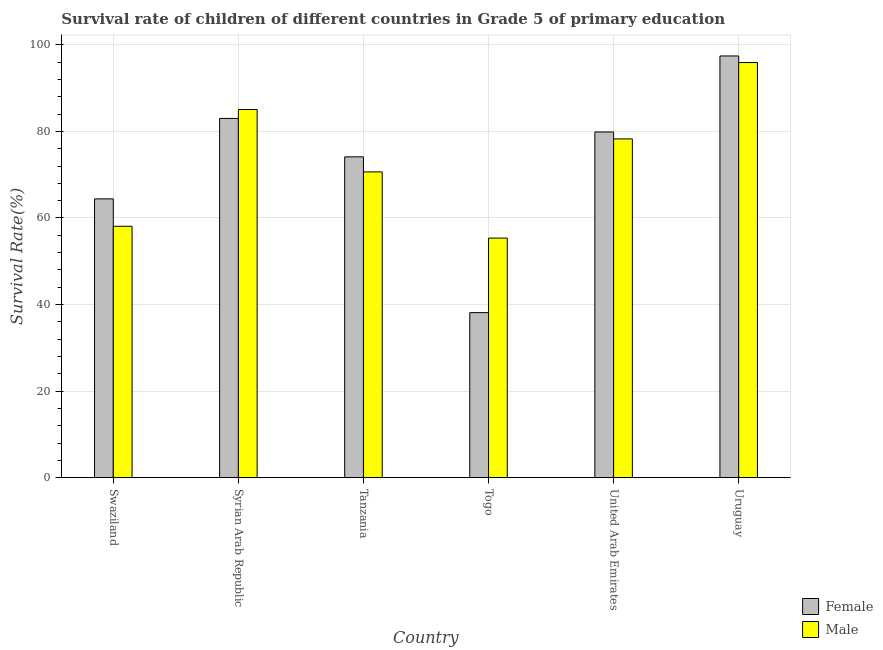How many groups of bars are there?
Offer a terse response. 6. Are the number of bars on each tick of the X-axis equal?
Offer a very short reply. Yes. What is the label of the 6th group of bars from the left?
Provide a succinct answer. Uruguay. In how many cases, is the number of bars for a given country not equal to the number of legend labels?
Provide a short and direct response. 0. What is the survival rate of male students in primary education in Togo?
Provide a succinct answer. 55.35. Across all countries, what is the maximum survival rate of male students in primary education?
Give a very brief answer. 95.9. Across all countries, what is the minimum survival rate of female students in primary education?
Offer a very short reply. 38.13. In which country was the survival rate of male students in primary education maximum?
Provide a succinct answer. Uruguay. In which country was the survival rate of male students in primary education minimum?
Your response must be concise. Togo. What is the total survival rate of male students in primary education in the graph?
Make the answer very short. 443.28. What is the difference between the survival rate of male students in primary education in Tanzania and that in Togo?
Your answer should be compact. 15.29. What is the difference between the survival rate of male students in primary education in United Arab Emirates and the survival rate of female students in primary education in Swaziland?
Provide a short and direct response. 13.85. What is the average survival rate of male students in primary education per country?
Offer a very short reply. 73.88. What is the difference between the survival rate of male students in primary education and survival rate of female students in primary education in Syrian Arab Republic?
Ensure brevity in your answer.  2.06. What is the ratio of the survival rate of male students in primary education in Syrian Arab Republic to that in Togo?
Provide a short and direct response. 1.54. What is the difference between the highest and the second highest survival rate of female students in primary education?
Your answer should be compact. 14.43. What is the difference between the highest and the lowest survival rate of female students in primary education?
Provide a succinct answer. 59.3. In how many countries, is the survival rate of female students in primary education greater than the average survival rate of female students in primary education taken over all countries?
Offer a terse response. 4. Is the sum of the survival rate of male students in primary education in Syrian Arab Republic and Uruguay greater than the maximum survival rate of female students in primary education across all countries?
Provide a succinct answer. Yes. Are all the bars in the graph horizontal?
Your answer should be very brief. No. What is the difference between two consecutive major ticks on the Y-axis?
Give a very brief answer. 20. Are the values on the major ticks of Y-axis written in scientific E-notation?
Your answer should be very brief. No. Where does the legend appear in the graph?
Your answer should be very brief. Bottom right. How are the legend labels stacked?
Your answer should be compact. Vertical. What is the title of the graph?
Give a very brief answer. Survival rate of children of different countries in Grade 5 of primary education. What is the label or title of the Y-axis?
Make the answer very short. Survival Rate(%). What is the Survival Rate(%) of Female in Swaziland?
Keep it short and to the point. 64.41. What is the Survival Rate(%) of Male in Swaziland?
Keep it short and to the point. 58.08. What is the Survival Rate(%) in Female in Syrian Arab Republic?
Provide a short and direct response. 82.99. What is the Survival Rate(%) of Male in Syrian Arab Republic?
Your answer should be very brief. 85.05. What is the Survival Rate(%) of Female in Tanzania?
Keep it short and to the point. 74.12. What is the Survival Rate(%) of Male in Tanzania?
Provide a short and direct response. 70.64. What is the Survival Rate(%) in Female in Togo?
Provide a succinct answer. 38.13. What is the Survival Rate(%) in Male in Togo?
Keep it short and to the point. 55.35. What is the Survival Rate(%) of Female in United Arab Emirates?
Give a very brief answer. 79.87. What is the Survival Rate(%) of Male in United Arab Emirates?
Offer a very short reply. 78.26. What is the Survival Rate(%) of Female in Uruguay?
Give a very brief answer. 97.43. What is the Survival Rate(%) of Male in Uruguay?
Ensure brevity in your answer.  95.9. Across all countries, what is the maximum Survival Rate(%) in Female?
Offer a terse response. 97.43. Across all countries, what is the maximum Survival Rate(%) in Male?
Give a very brief answer. 95.9. Across all countries, what is the minimum Survival Rate(%) of Female?
Your response must be concise. 38.13. Across all countries, what is the minimum Survival Rate(%) in Male?
Make the answer very short. 55.35. What is the total Survival Rate(%) in Female in the graph?
Provide a short and direct response. 436.94. What is the total Survival Rate(%) in Male in the graph?
Your answer should be very brief. 443.28. What is the difference between the Survival Rate(%) of Female in Swaziland and that in Syrian Arab Republic?
Provide a succinct answer. -18.58. What is the difference between the Survival Rate(%) in Male in Swaziland and that in Syrian Arab Republic?
Provide a succinct answer. -26.97. What is the difference between the Survival Rate(%) in Female in Swaziland and that in Tanzania?
Your response must be concise. -9.71. What is the difference between the Survival Rate(%) in Male in Swaziland and that in Tanzania?
Your answer should be compact. -12.56. What is the difference between the Survival Rate(%) of Female in Swaziland and that in Togo?
Offer a terse response. 26.28. What is the difference between the Survival Rate(%) of Male in Swaziland and that in Togo?
Your response must be concise. 2.73. What is the difference between the Survival Rate(%) of Female in Swaziland and that in United Arab Emirates?
Make the answer very short. -15.45. What is the difference between the Survival Rate(%) of Male in Swaziland and that in United Arab Emirates?
Offer a terse response. -20.18. What is the difference between the Survival Rate(%) in Female in Swaziland and that in Uruguay?
Give a very brief answer. -33.02. What is the difference between the Survival Rate(%) in Male in Swaziland and that in Uruguay?
Offer a very short reply. -37.82. What is the difference between the Survival Rate(%) in Female in Syrian Arab Republic and that in Tanzania?
Provide a succinct answer. 8.87. What is the difference between the Survival Rate(%) of Male in Syrian Arab Republic and that in Tanzania?
Offer a very short reply. 14.41. What is the difference between the Survival Rate(%) in Female in Syrian Arab Republic and that in Togo?
Offer a very short reply. 44.87. What is the difference between the Survival Rate(%) of Male in Syrian Arab Republic and that in Togo?
Offer a terse response. 29.7. What is the difference between the Survival Rate(%) of Female in Syrian Arab Republic and that in United Arab Emirates?
Give a very brief answer. 3.13. What is the difference between the Survival Rate(%) in Male in Syrian Arab Republic and that in United Arab Emirates?
Offer a terse response. 6.79. What is the difference between the Survival Rate(%) in Female in Syrian Arab Republic and that in Uruguay?
Offer a terse response. -14.43. What is the difference between the Survival Rate(%) in Male in Syrian Arab Republic and that in Uruguay?
Your response must be concise. -10.85. What is the difference between the Survival Rate(%) in Female in Tanzania and that in Togo?
Keep it short and to the point. 35.99. What is the difference between the Survival Rate(%) in Male in Tanzania and that in Togo?
Make the answer very short. 15.29. What is the difference between the Survival Rate(%) in Female in Tanzania and that in United Arab Emirates?
Keep it short and to the point. -5.75. What is the difference between the Survival Rate(%) in Male in Tanzania and that in United Arab Emirates?
Ensure brevity in your answer.  -7.62. What is the difference between the Survival Rate(%) in Female in Tanzania and that in Uruguay?
Offer a very short reply. -23.31. What is the difference between the Survival Rate(%) in Male in Tanzania and that in Uruguay?
Provide a succinct answer. -25.26. What is the difference between the Survival Rate(%) in Female in Togo and that in United Arab Emirates?
Your answer should be very brief. -41.74. What is the difference between the Survival Rate(%) in Male in Togo and that in United Arab Emirates?
Make the answer very short. -22.91. What is the difference between the Survival Rate(%) of Female in Togo and that in Uruguay?
Provide a succinct answer. -59.3. What is the difference between the Survival Rate(%) of Male in Togo and that in Uruguay?
Offer a terse response. -40.55. What is the difference between the Survival Rate(%) in Female in United Arab Emirates and that in Uruguay?
Offer a very short reply. -17.56. What is the difference between the Survival Rate(%) of Male in United Arab Emirates and that in Uruguay?
Give a very brief answer. -17.64. What is the difference between the Survival Rate(%) in Female in Swaziland and the Survival Rate(%) in Male in Syrian Arab Republic?
Ensure brevity in your answer.  -20.64. What is the difference between the Survival Rate(%) of Female in Swaziland and the Survival Rate(%) of Male in Tanzania?
Keep it short and to the point. -6.23. What is the difference between the Survival Rate(%) of Female in Swaziland and the Survival Rate(%) of Male in Togo?
Provide a succinct answer. 9.06. What is the difference between the Survival Rate(%) of Female in Swaziland and the Survival Rate(%) of Male in United Arab Emirates?
Offer a very short reply. -13.85. What is the difference between the Survival Rate(%) in Female in Swaziland and the Survival Rate(%) in Male in Uruguay?
Make the answer very short. -31.49. What is the difference between the Survival Rate(%) of Female in Syrian Arab Republic and the Survival Rate(%) of Male in Tanzania?
Your answer should be compact. 12.35. What is the difference between the Survival Rate(%) of Female in Syrian Arab Republic and the Survival Rate(%) of Male in Togo?
Make the answer very short. 27.64. What is the difference between the Survival Rate(%) of Female in Syrian Arab Republic and the Survival Rate(%) of Male in United Arab Emirates?
Give a very brief answer. 4.73. What is the difference between the Survival Rate(%) of Female in Syrian Arab Republic and the Survival Rate(%) of Male in Uruguay?
Ensure brevity in your answer.  -12.91. What is the difference between the Survival Rate(%) in Female in Tanzania and the Survival Rate(%) in Male in Togo?
Offer a very short reply. 18.77. What is the difference between the Survival Rate(%) in Female in Tanzania and the Survival Rate(%) in Male in United Arab Emirates?
Give a very brief answer. -4.14. What is the difference between the Survival Rate(%) of Female in Tanzania and the Survival Rate(%) of Male in Uruguay?
Your answer should be very brief. -21.78. What is the difference between the Survival Rate(%) of Female in Togo and the Survival Rate(%) of Male in United Arab Emirates?
Offer a terse response. -40.14. What is the difference between the Survival Rate(%) in Female in Togo and the Survival Rate(%) in Male in Uruguay?
Provide a succinct answer. -57.78. What is the difference between the Survival Rate(%) in Female in United Arab Emirates and the Survival Rate(%) in Male in Uruguay?
Give a very brief answer. -16.04. What is the average Survival Rate(%) in Female per country?
Provide a succinct answer. 72.82. What is the average Survival Rate(%) in Male per country?
Keep it short and to the point. 73.88. What is the difference between the Survival Rate(%) of Female and Survival Rate(%) of Male in Swaziland?
Ensure brevity in your answer.  6.33. What is the difference between the Survival Rate(%) in Female and Survival Rate(%) in Male in Syrian Arab Republic?
Provide a succinct answer. -2.06. What is the difference between the Survival Rate(%) of Female and Survival Rate(%) of Male in Tanzania?
Give a very brief answer. 3.48. What is the difference between the Survival Rate(%) of Female and Survival Rate(%) of Male in Togo?
Your response must be concise. -17.22. What is the difference between the Survival Rate(%) in Female and Survival Rate(%) in Male in United Arab Emirates?
Offer a terse response. 1.6. What is the difference between the Survival Rate(%) of Female and Survival Rate(%) of Male in Uruguay?
Ensure brevity in your answer.  1.52. What is the ratio of the Survival Rate(%) of Female in Swaziland to that in Syrian Arab Republic?
Offer a terse response. 0.78. What is the ratio of the Survival Rate(%) of Male in Swaziland to that in Syrian Arab Republic?
Provide a succinct answer. 0.68. What is the ratio of the Survival Rate(%) in Female in Swaziland to that in Tanzania?
Give a very brief answer. 0.87. What is the ratio of the Survival Rate(%) of Male in Swaziland to that in Tanzania?
Your answer should be very brief. 0.82. What is the ratio of the Survival Rate(%) in Female in Swaziland to that in Togo?
Give a very brief answer. 1.69. What is the ratio of the Survival Rate(%) of Male in Swaziland to that in Togo?
Make the answer very short. 1.05. What is the ratio of the Survival Rate(%) in Female in Swaziland to that in United Arab Emirates?
Your answer should be very brief. 0.81. What is the ratio of the Survival Rate(%) in Male in Swaziland to that in United Arab Emirates?
Offer a terse response. 0.74. What is the ratio of the Survival Rate(%) in Female in Swaziland to that in Uruguay?
Provide a succinct answer. 0.66. What is the ratio of the Survival Rate(%) of Male in Swaziland to that in Uruguay?
Your response must be concise. 0.61. What is the ratio of the Survival Rate(%) of Female in Syrian Arab Republic to that in Tanzania?
Provide a short and direct response. 1.12. What is the ratio of the Survival Rate(%) in Male in Syrian Arab Republic to that in Tanzania?
Provide a succinct answer. 1.2. What is the ratio of the Survival Rate(%) in Female in Syrian Arab Republic to that in Togo?
Provide a succinct answer. 2.18. What is the ratio of the Survival Rate(%) of Male in Syrian Arab Republic to that in Togo?
Your response must be concise. 1.54. What is the ratio of the Survival Rate(%) in Female in Syrian Arab Republic to that in United Arab Emirates?
Ensure brevity in your answer.  1.04. What is the ratio of the Survival Rate(%) of Male in Syrian Arab Republic to that in United Arab Emirates?
Give a very brief answer. 1.09. What is the ratio of the Survival Rate(%) in Female in Syrian Arab Republic to that in Uruguay?
Give a very brief answer. 0.85. What is the ratio of the Survival Rate(%) of Male in Syrian Arab Republic to that in Uruguay?
Provide a short and direct response. 0.89. What is the ratio of the Survival Rate(%) of Female in Tanzania to that in Togo?
Your answer should be very brief. 1.94. What is the ratio of the Survival Rate(%) of Male in Tanzania to that in Togo?
Your answer should be very brief. 1.28. What is the ratio of the Survival Rate(%) in Female in Tanzania to that in United Arab Emirates?
Ensure brevity in your answer.  0.93. What is the ratio of the Survival Rate(%) of Male in Tanzania to that in United Arab Emirates?
Give a very brief answer. 0.9. What is the ratio of the Survival Rate(%) of Female in Tanzania to that in Uruguay?
Provide a succinct answer. 0.76. What is the ratio of the Survival Rate(%) in Male in Tanzania to that in Uruguay?
Keep it short and to the point. 0.74. What is the ratio of the Survival Rate(%) in Female in Togo to that in United Arab Emirates?
Ensure brevity in your answer.  0.48. What is the ratio of the Survival Rate(%) in Male in Togo to that in United Arab Emirates?
Provide a succinct answer. 0.71. What is the ratio of the Survival Rate(%) of Female in Togo to that in Uruguay?
Your response must be concise. 0.39. What is the ratio of the Survival Rate(%) in Male in Togo to that in Uruguay?
Provide a succinct answer. 0.58. What is the ratio of the Survival Rate(%) of Female in United Arab Emirates to that in Uruguay?
Offer a terse response. 0.82. What is the ratio of the Survival Rate(%) of Male in United Arab Emirates to that in Uruguay?
Make the answer very short. 0.82. What is the difference between the highest and the second highest Survival Rate(%) of Female?
Offer a very short reply. 14.43. What is the difference between the highest and the second highest Survival Rate(%) of Male?
Your response must be concise. 10.85. What is the difference between the highest and the lowest Survival Rate(%) in Female?
Keep it short and to the point. 59.3. What is the difference between the highest and the lowest Survival Rate(%) of Male?
Provide a succinct answer. 40.55. 